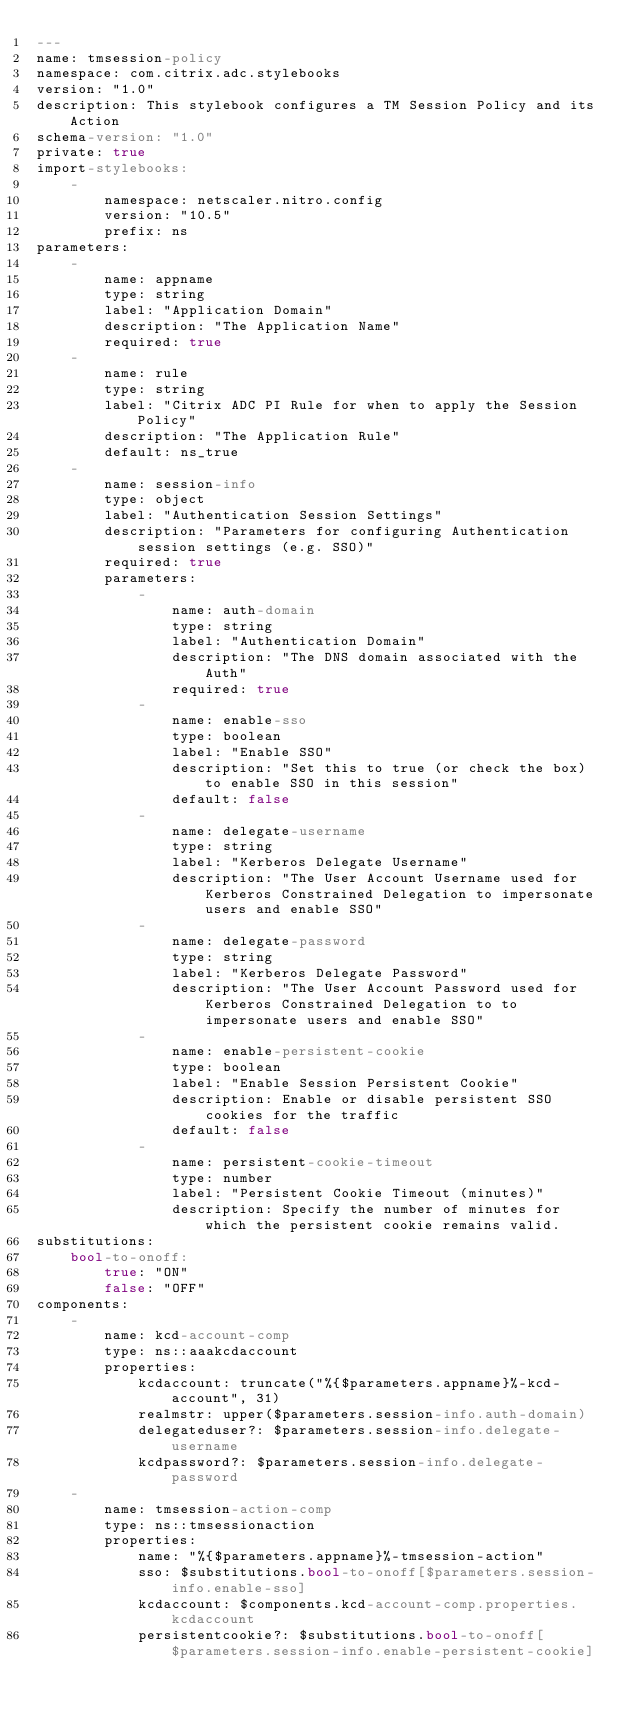<code> <loc_0><loc_0><loc_500><loc_500><_YAML_>--- 
name: tmsession-policy
namespace: com.citrix.adc.stylebooks
version: "1.0"
description: This stylebook configures a TM Session Policy and its Action
schema-version: "1.0"
private: true
import-stylebooks: 
    - 
        namespace: netscaler.nitro.config
        version: "10.5"
        prefix: ns
parameters:
    -
        name: appname
        type: string
        label: "Application Domain"
        description: "The Application Name"
        required: true
    -
        name: rule
        type: string
        label: "Citrix ADC PI Rule for when to apply the Session Policy"
        description: "The Application Rule"
        default: ns_true
    -
        name: session-info
        type: object
        label: "Authentication Session Settings"
        description: "Parameters for configuring Authentication session settings (e.g. SSO)"
        required: true    
        parameters:
            -
                name: auth-domain
                type: string
                label: "Authentication Domain"
                description: "The DNS domain associated with the Auth"
                required: true
            - 
                name: enable-sso
                type: boolean
                label: "Enable SSO"
                description: "Set this to true (or check the box) to enable SSO in this session"
                default: false
            - 
                name: delegate-username
                type: string
                label: "Kerberos Delegate Username"
                description: "The User Account Username used for Kerberos Constrained Delegation to impersonate users and enable SSO"
            - 
                name: delegate-password
                type: string
                label: "Kerberos Delegate Password"
                description: "The User Account Password used for Kerberos Constrained Delegation to to impersonate users and enable SSO"
            -
                name: enable-persistent-cookie
                type: boolean
                label: "Enable Session Persistent Cookie"
                description: Enable or disable persistent SSO cookies for the traffic
                default: false
            -
                name: persistent-cookie-timeout
                type: number
                label: "Persistent Cookie Timeout (minutes)"
                description: Specify the number of minutes for which the persistent cookie remains valid.
substitutions:
    bool-to-onoff: 
        true: "ON"
        false: "OFF"
components:
    -
        name: kcd-account-comp
        type: ns::aaakcdaccount
        properties:
            kcdaccount: truncate("%{$parameters.appname}%-kcd-account", 31)
            realmstr: upper($parameters.session-info.auth-domain)
            delegateduser?: $parameters.session-info.delegate-username
            kcdpassword?: $parameters.session-info.delegate-password
    -
        name: tmsession-action-comp
        type: ns::tmsessionaction
        properties:
            name: "%{$parameters.appname}%-tmsession-action"
            sso: $substitutions.bool-to-onoff[$parameters.session-info.enable-sso]
            kcdaccount: $components.kcd-account-comp.properties.kcdaccount
            persistentcookie?: $substitutions.bool-to-onoff[$parameters.session-info.enable-persistent-cookie]</code> 